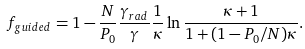<formula> <loc_0><loc_0><loc_500><loc_500>f _ { g u i d e d } = 1 - \frac { N } { P _ { 0 } } \frac { \gamma _ { r a d } } { \gamma } \frac { 1 } { \kappa } \ln \frac { \kappa + 1 } { 1 + ( 1 - P _ { 0 } / N ) \kappa } .</formula> 